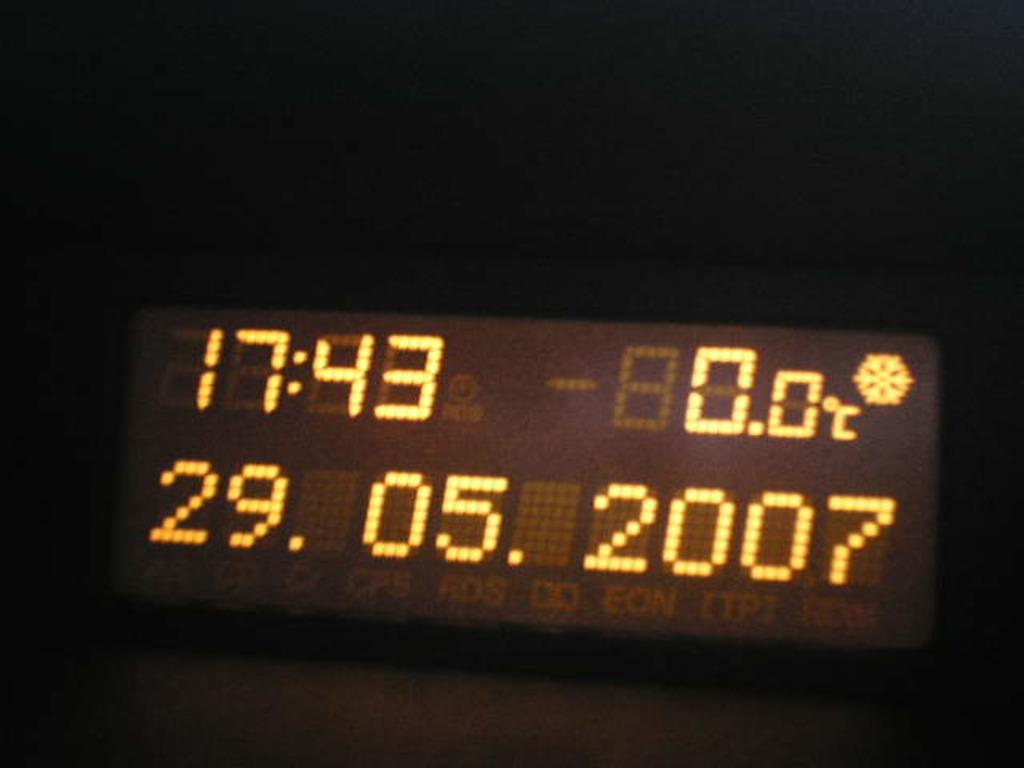What time is listed?
Keep it short and to the point. 17:43. 